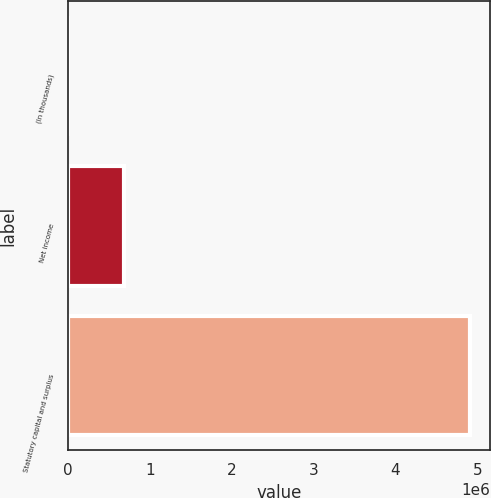Convert chart to OTSL. <chart><loc_0><loc_0><loc_500><loc_500><bar_chart><fcel>(In thousands)<fcel>Net income<fcel>Statutory capital and surplus<nl><fcel>2013<fcel>680418<fcel>4.90801e+06<nl></chart> 